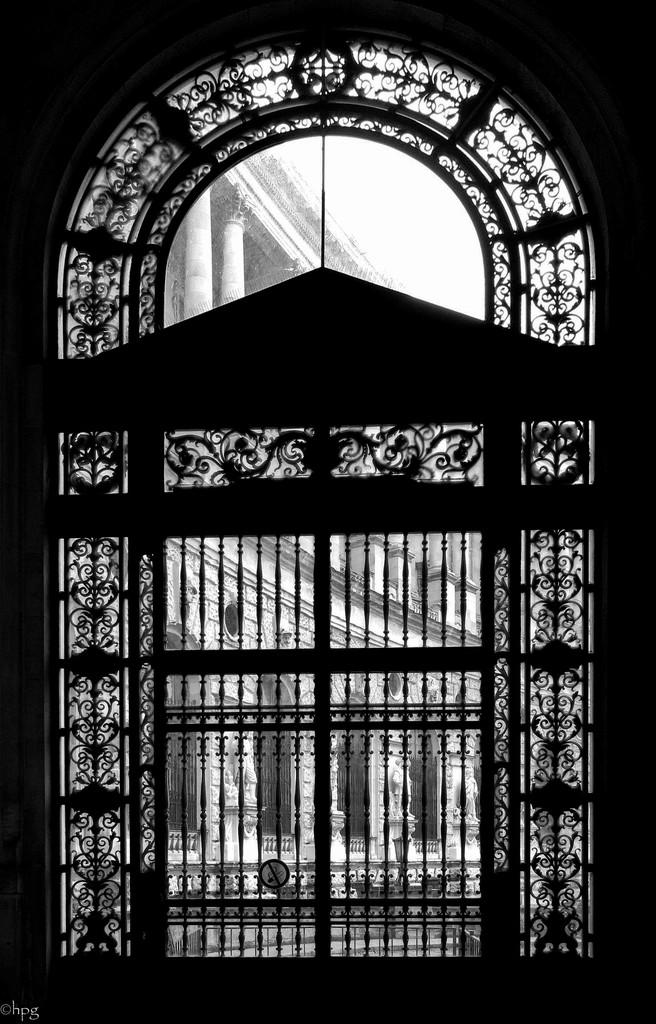What is the main structure in the image? There is a gate in the image. How is the gate positioned in relation to other structures? The gate is under an arch. What can be seen behind the gate in the image? There is a big building behind the gate. What type of whip can be seen hanging from the gate in the image? There is no whip present in the image; it only features a gate, an arch, and a big building. 